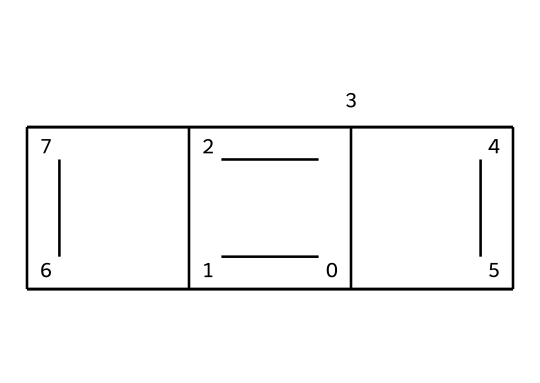How many carbon atoms are in the structure? By analyzing the SMILES representation, we can see that each letter "C" indicates a carbon atom. There are five "C" letters present in the structure, indicating a total of five carbon atoms.
Answer: five What type of bonds are primarily present in this molecule? The presence of multiple connected carbon atoms in a ring-like structure indicates that the molecule likely contains aromatic bonds, characteristic of graphite materials, which include double bonds between carbons.
Answer: aromatic What is the degree of saturation of the structure? The presence of alternating double bonds implies that the structure has a high degree of unsaturation. Each double bond reduces the number of hydrogen atoms in proportion to what saturated carbon would have, indicating that it is significantly unsaturated.
Answer: unsaturated What is this molecule's primary application in geology? Graphite lubricants are primarily used for reducing friction in drilling operations, which helps in sampling geological cores effectively without damaging the sample or the drilling equipment.
Answer: lubrication What physical property of this structure contributes to its lubricating ability? The layered structure of graphite allows its layers to slide over one another easily, thus providing low friction necessary for effective lubrication.
Answer: layered structure 